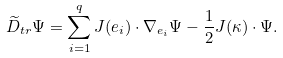Convert formula to latex. <formula><loc_0><loc_0><loc_500><loc_500>\widetilde { D } _ { t r } \Psi = \sum _ { i = 1 } ^ { q } J ( e _ { i } ) \cdot \nabla _ { e _ { i } } \Psi - \frac { 1 } { 2 } J ( \kappa ) \cdot \Psi .</formula> 